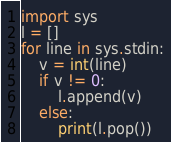Convert code to text. <code><loc_0><loc_0><loc_500><loc_500><_Python_>import sys
l = []
for line in sys.stdin:
    v = int(line)
    if v != 0:
        l.append(v)
    else:
        print(l.pop())</code> 